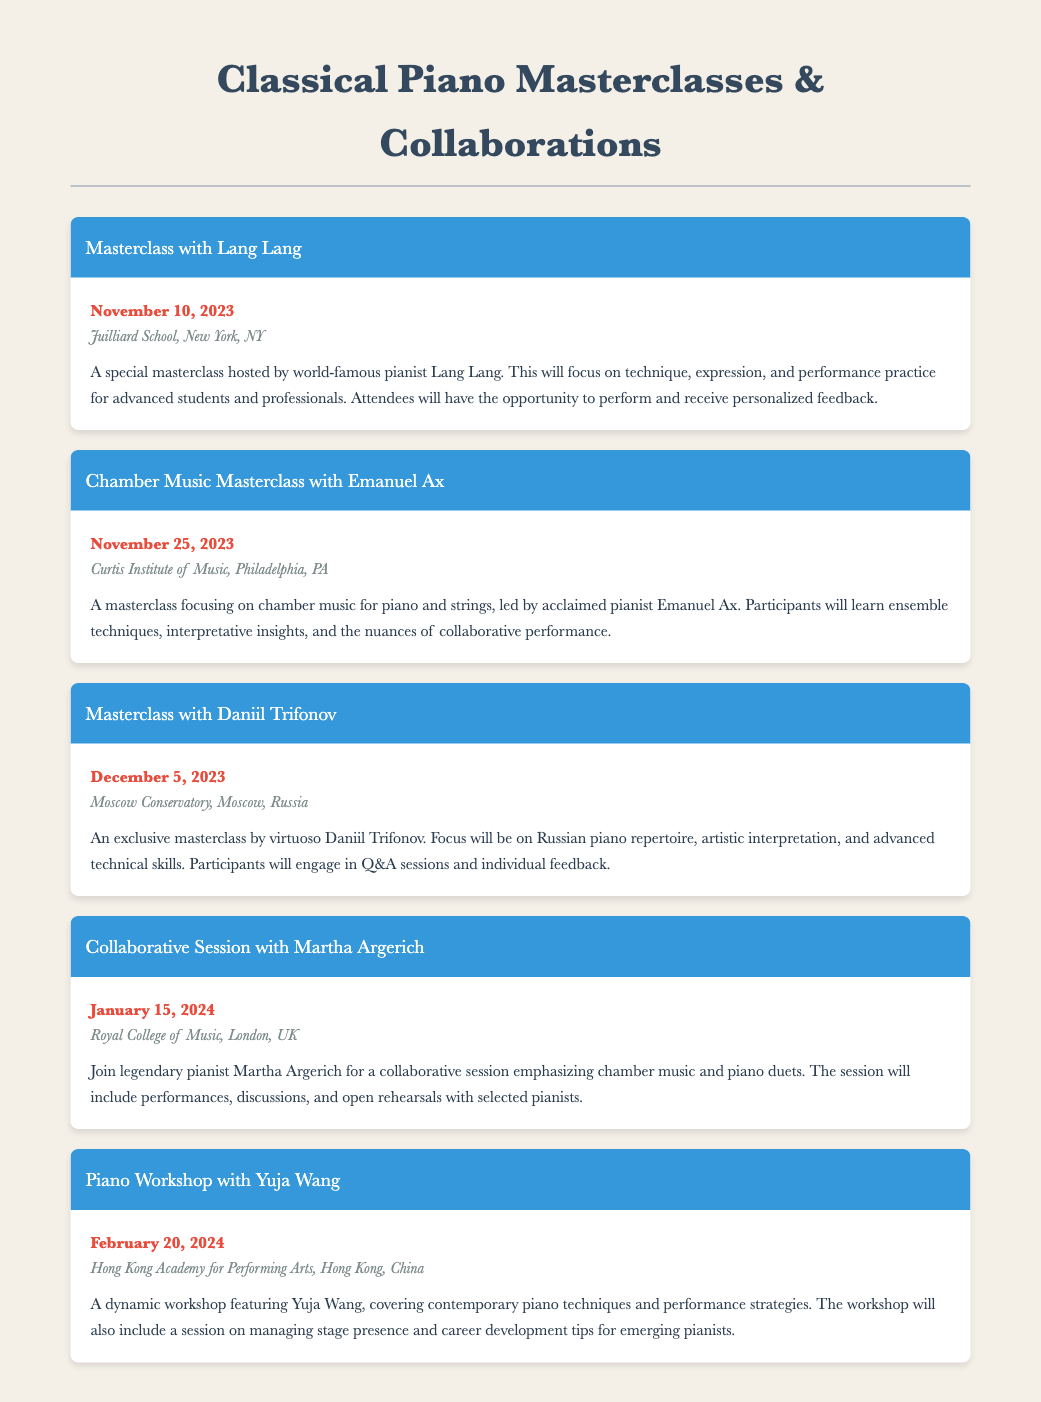What is the date of the masterclass with Lang Lang? The date of the masterclass is specified in the document under the event details for Lang Lang.
Answer: November 10, 2023 Where is the Chamber Music Masterclass with Emanuel Ax held? The location is mentioned in the event details for Emanuel Ax's masterclass.
Answer: Curtis Institute of Music, Philadelphia, PA Who will host the collaborative session on January 15, 2024? The host of the collaborative session is noted in the event description for that date.
Answer: Martha Argerich What is the primary focus of the masterclass with Daniil Trifonov? The focus of the masterclass is stated in the description for the event featuring Daniil Trifonov.
Answer: Russian piano repertoire How many masterclasses or collaborative sessions are listed in the document? The total number of events can be counted from the document's event sections.
Answer: 5 What is the location of the piano workshop with Yuja Wang? The location is mentioned in the event details for Yuja Wang's workshop.
Answer: Hong Kong Academy for Performing Arts, Hong Kong, China What type of music will be emphasized during the collaborative session with Martha Argerich? The emphasis of the collaborative session is described in the event details for Martha Argerich's session.
Answer: Chamber music and piano duets What is the unique aspect of Yuja Wang's piano workshop? The unique aspect is highlighted in the workshop's description.
Answer: Managing stage presence and career development tips 